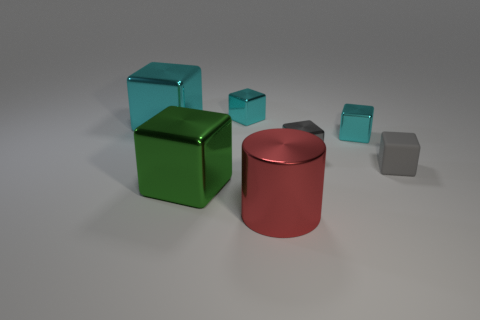Subtract all blue cylinders. How many cyan cubes are left? 3 Subtract all green blocks. How many blocks are left? 5 Subtract all gray shiny blocks. How many blocks are left? 5 Subtract all yellow blocks. Subtract all red cylinders. How many blocks are left? 6 Add 2 tiny yellow matte blocks. How many objects exist? 9 Subtract all blocks. How many objects are left? 1 Subtract 0 blue spheres. How many objects are left? 7 Subtract all gray matte objects. Subtract all tiny matte objects. How many objects are left? 5 Add 5 gray shiny cubes. How many gray shiny cubes are left? 6 Add 3 brown rubber cylinders. How many brown rubber cylinders exist? 3 